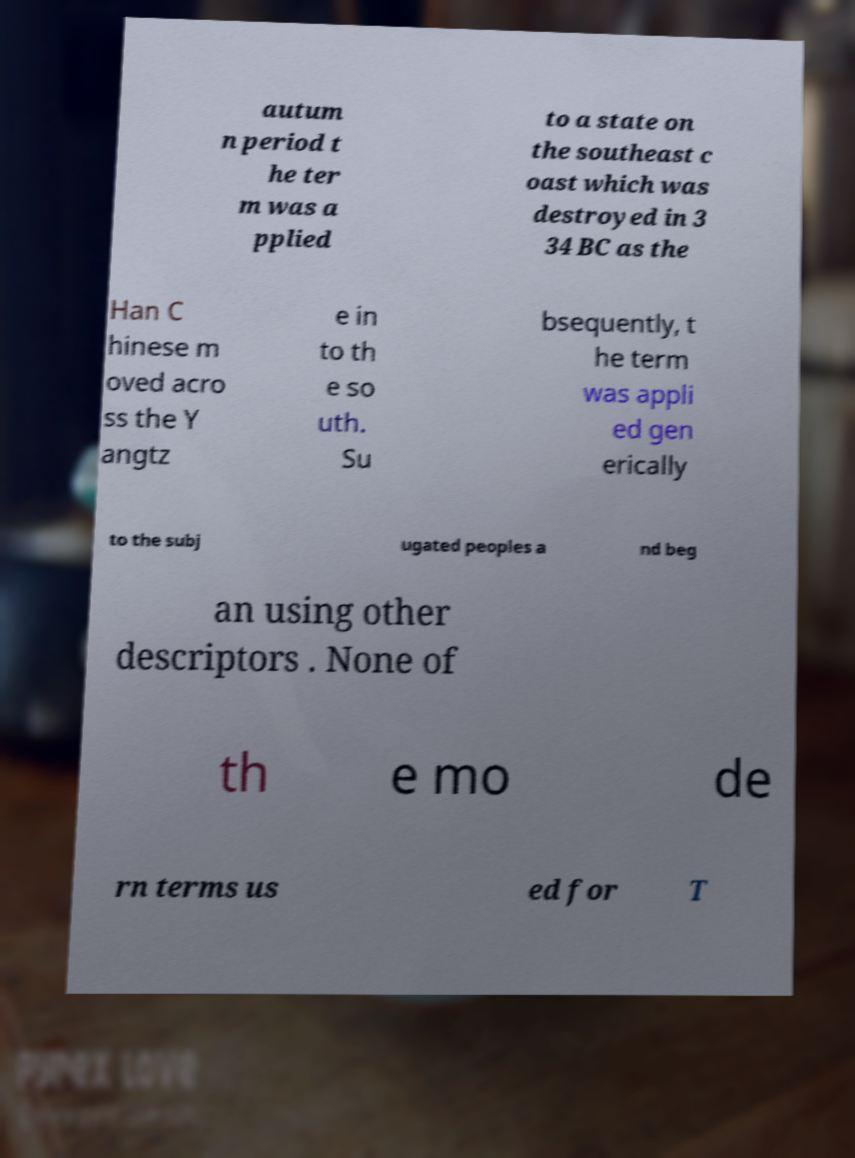There's text embedded in this image that I need extracted. Can you transcribe it verbatim? autum n period t he ter m was a pplied to a state on the southeast c oast which was destroyed in 3 34 BC as the Han C hinese m oved acro ss the Y angtz e in to th e so uth. Su bsequently, t he term was appli ed gen erically to the subj ugated peoples a nd beg an using other descriptors . None of th e mo de rn terms us ed for T 